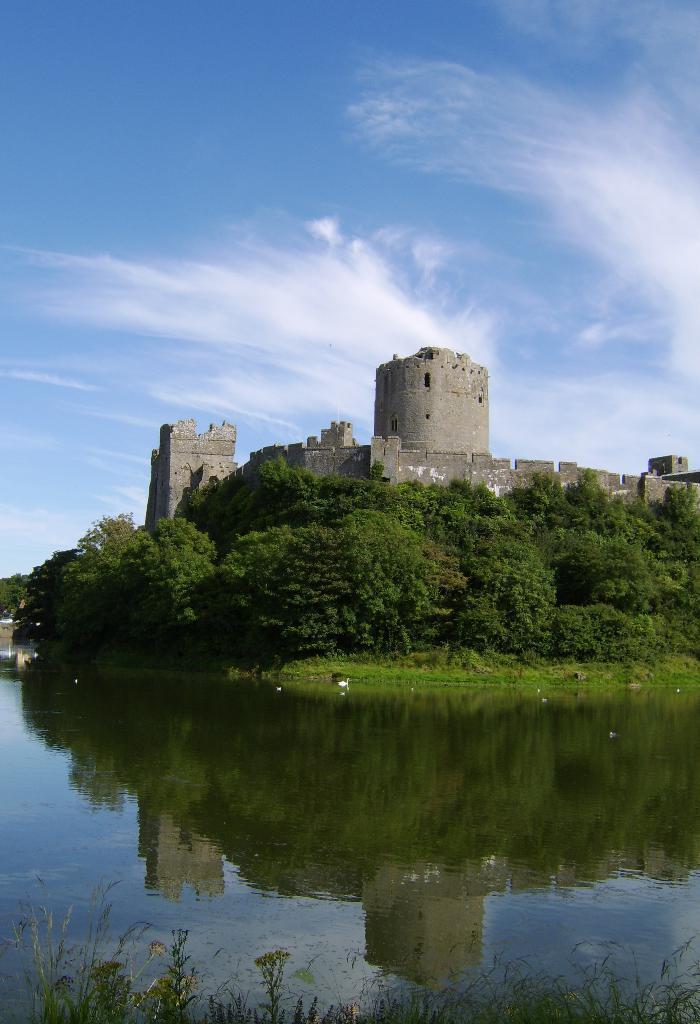Can you describe this image briefly? In this image there is the sky towards the top of the image, there are clouds in the sky, there is a monument, there are trees, there is water, there are plants towards the bottom of the image. 